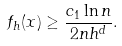Convert formula to latex. <formula><loc_0><loc_0><loc_500><loc_500>f _ { h } ( x ) \geq \frac { c _ { 1 } \ln n } { 2 n h ^ { d } } .</formula> 